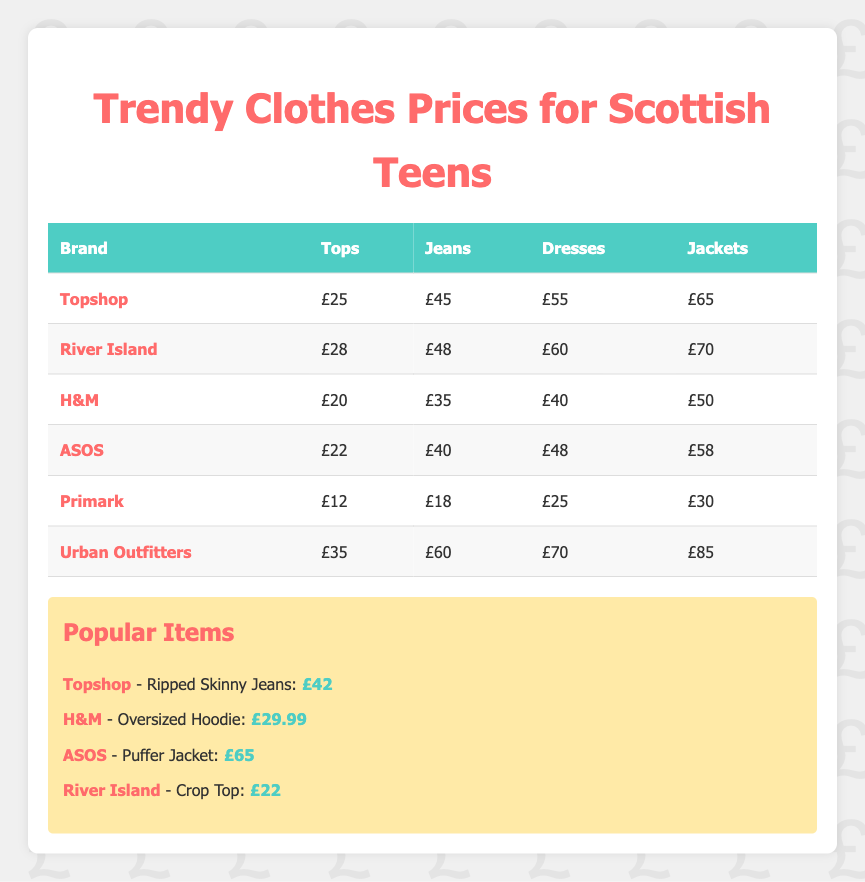What is the average price of jeans from Topshop? The average price for jeans from Topshop is specifically listed as £45 in the table.
Answer: £45 Which brand has the most expensive jackets? Urban Outfitters has the most expensive jackets at £85, as per the prices listed in the table for jackets across all brands.
Answer: Urban Outfitters What is the total average price of tops and dresses from H&M? The average price of tops from H&M is £20 and the average price of dresses is £40. Adding these together gives £20 + £40 = £60.
Answer: £60 Is the average price of jeans from River Island higher than from H&M? The average price of jeans from River Island is £48, while from H&M it is £35. Since £48 is greater than £35, the statement is true.
Answer: Yes If you compare the top prices of Topshop and ASOS, which one is cheaper? Topshop has a top price of £25 while ASOS has a top price of £22. £22 is less than £25, making ASOS cheaper for tops.
Answer: ASOS What is the lowest average price for tops among all brands listed? The lowest average price for tops is £12 from Primark, as it is the smallest value in the tops column across all brands mentioned.
Answer: £12 Calculate the difference in average price of dresses between Urban Outfitters and River Island. The average price of dresses from Urban Outfitters is £70, while from River Island it is £60. The difference is £70 - £60 = £10.
Answer: £10 Is Primark's average price for jackets less than £35? Primark's average price for jackets is £30, which is indeed less than £35. Therefore, this statement is true.
Answer: Yes What is the average price of a dress across all brands? To find the average price, sum all the dress prices: £55 (Topshop) + £60 (River Island) + £40 (H&M) + £48 (ASOS) + £25 (Primark) + £70 (Urban Outfitters) = £298. Divide by the number of brands, which is 6. So, £298/6 = £49.67.
Answer: £49.67 